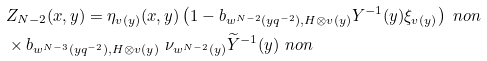<formula> <loc_0><loc_0><loc_500><loc_500>& Z _ { N - 2 } ( x , y ) = \eta _ { v ( y ) } ( x , y ) \left ( 1 - b _ { w ^ { N - 2 } ( y q ^ { - 2 } ) , H \otimes v ( y ) } Y ^ { - 1 } ( y ) \xi _ { v ( y ) } \right ) \ n o n \\ & \times b _ { w ^ { N - 3 } ( y q ^ { - 2 } ) , H \otimes v ( y ) } \ \nu _ { w ^ { N - 2 } ( y ) } \widetilde { Y } ^ { - 1 } ( y ) \ n o n</formula> 